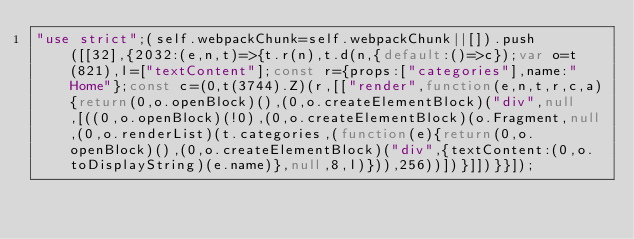<code> <loc_0><loc_0><loc_500><loc_500><_JavaScript_>"use strict";(self.webpackChunk=self.webpackChunk||[]).push([[32],{2032:(e,n,t)=>{t.r(n),t.d(n,{default:()=>c});var o=t(821),l=["textContent"];const r={props:["categories"],name:"Home"};const c=(0,t(3744).Z)(r,[["render",function(e,n,t,r,c,a){return(0,o.openBlock)(),(0,o.createElementBlock)("div",null,[((0,o.openBlock)(!0),(0,o.createElementBlock)(o.Fragment,null,(0,o.renderList)(t.categories,(function(e){return(0,o.openBlock)(),(0,o.createElementBlock)("div",{textContent:(0,o.toDisplayString)(e.name)},null,8,l)})),256))])}]])}}]);</code> 